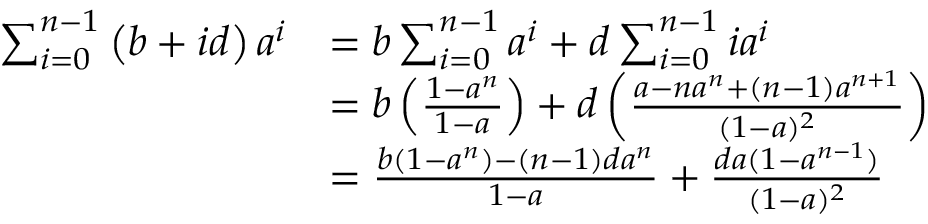<formula> <loc_0><loc_0><loc_500><loc_500>{ \begin{array} { r l } { \sum _ { i = 0 } ^ { n - 1 } \left ( b + i d \right ) a ^ { i } } & { = b \sum _ { i = 0 } ^ { n - 1 } a ^ { i } + d \sum _ { i = 0 } ^ { n - 1 } i a ^ { i } } \\ & { = b \left ( { \frac { 1 - a ^ { n } } { 1 - a } } \right ) + d \left ( { \frac { a - n a ^ { n } + ( n - 1 ) a ^ { n + 1 } } { ( 1 - a ) ^ { 2 } } } \right ) } \\ & { = { \frac { b ( 1 - a ^ { n } ) - ( n - 1 ) d a ^ { n } } { 1 - a } } + { \frac { d a ( 1 - a ^ { n - 1 } ) } { ( 1 - a ) ^ { 2 } } } } \end{array} }</formula> 